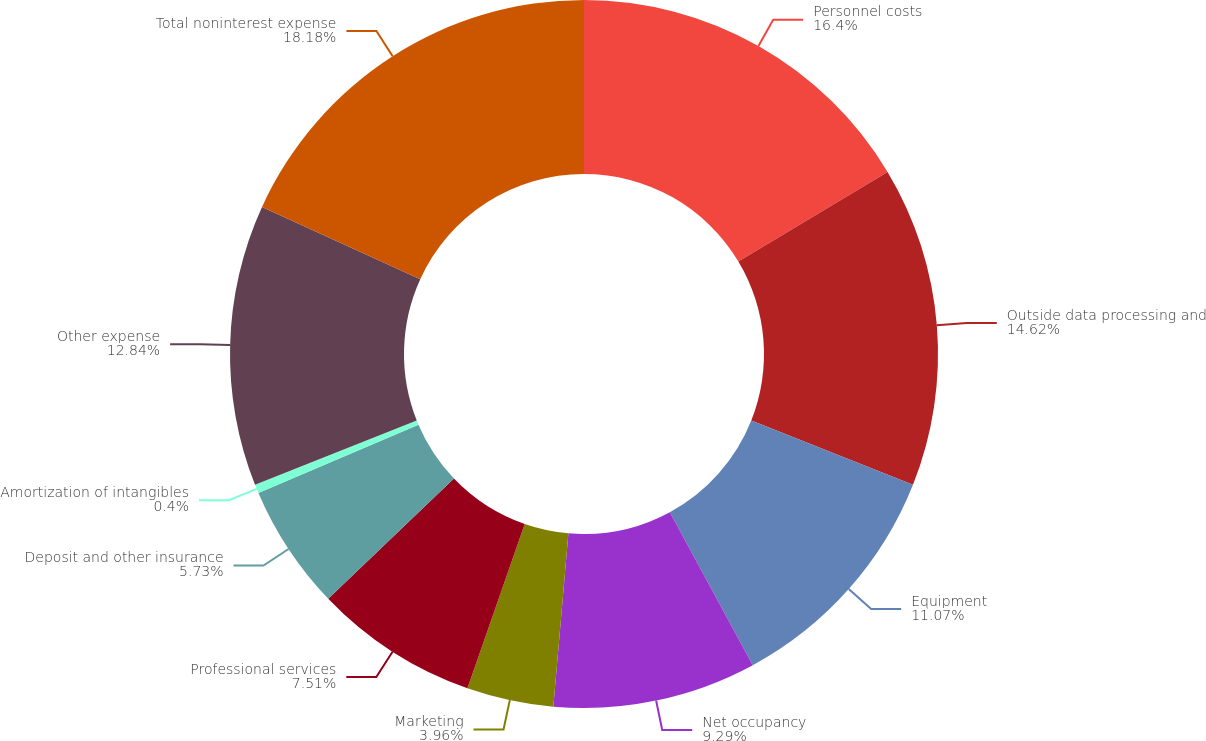<chart> <loc_0><loc_0><loc_500><loc_500><pie_chart><fcel>Personnel costs<fcel>Outside data processing and<fcel>Equipment<fcel>Net occupancy<fcel>Marketing<fcel>Professional services<fcel>Deposit and other insurance<fcel>Amortization of intangibles<fcel>Other expense<fcel>Total noninterest expense<nl><fcel>16.4%<fcel>14.62%<fcel>11.07%<fcel>9.29%<fcel>3.96%<fcel>7.51%<fcel>5.73%<fcel>0.4%<fcel>12.84%<fcel>18.18%<nl></chart> 